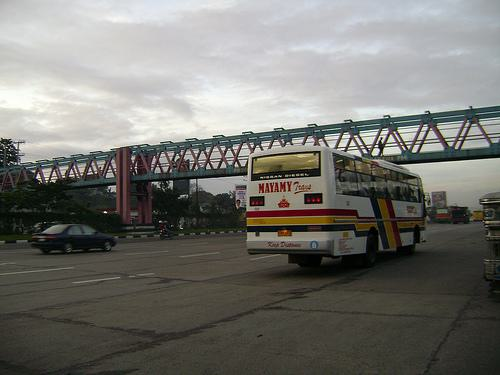How many buss are there in the image? There is one bus visible in the image, captured on the road with the backdrop of a distinct red pedestrian bridge. 